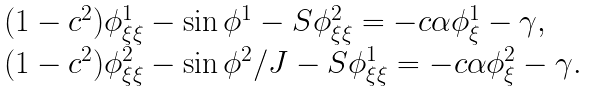Convert formula to latex. <formula><loc_0><loc_0><loc_500><loc_500>\begin{array} { l l } ( 1 - c ^ { 2 } ) \phi ^ { 1 } _ { \xi \xi } - \sin { \phi ^ { 1 } } - S \phi ^ { 2 } _ { \xi \xi } = - c \alpha \phi ^ { 1 } _ { \xi } - \gamma , \\ ( 1 - c ^ { 2 } ) \phi ^ { 2 } _ { \xi \xi } - \sin { \phi ^ { 2 } } / J - S \phi ^ { 1 } _ { \xi \xi } = - c \alpha \phi ^ { 2 } _ { \xi } - \gamma . \end{array}</formula> 